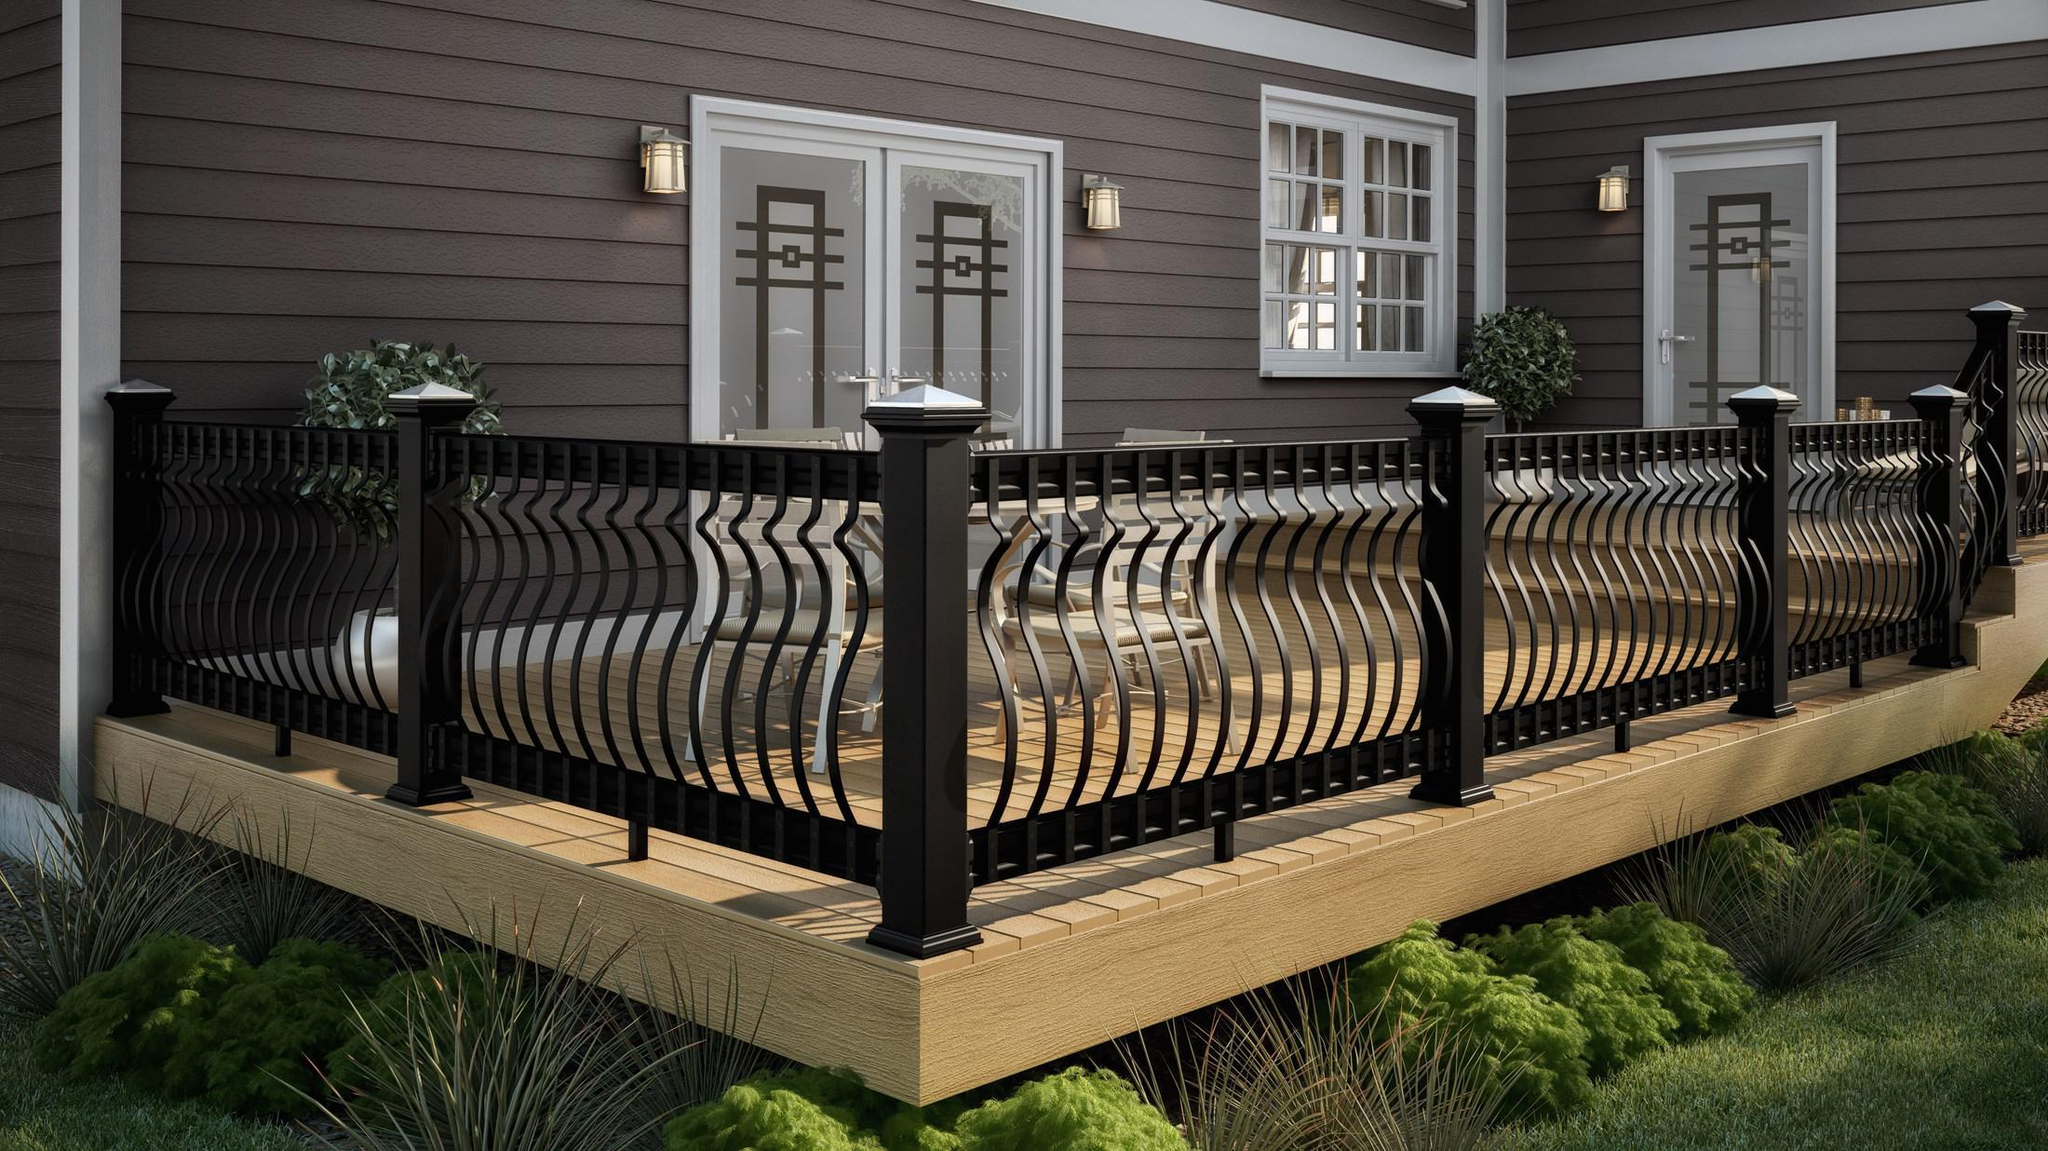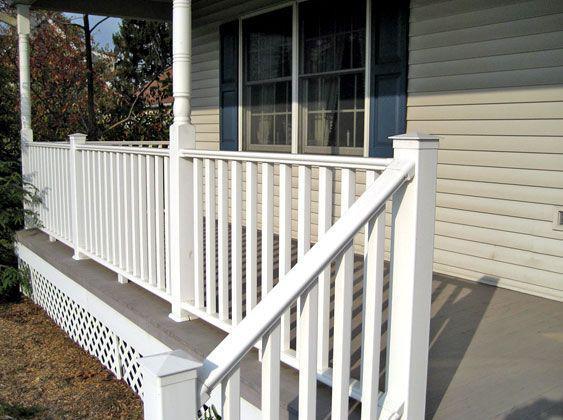The first image is the image on the left, the second image is the image on the right. For the images displayed, is the sentence "The right image shows a deck with a jutting section instead of a straight across front, and white corner posts with dark brown flat boards atop the handrails." factually correct? Answer yes or no. No. The first image is the image on the left, the second image is the image on the right. Examine the images to the left and right. Is the description "One of the railings has white main posts with smaller black posts in between." accurate? Answer yes or no. No. 